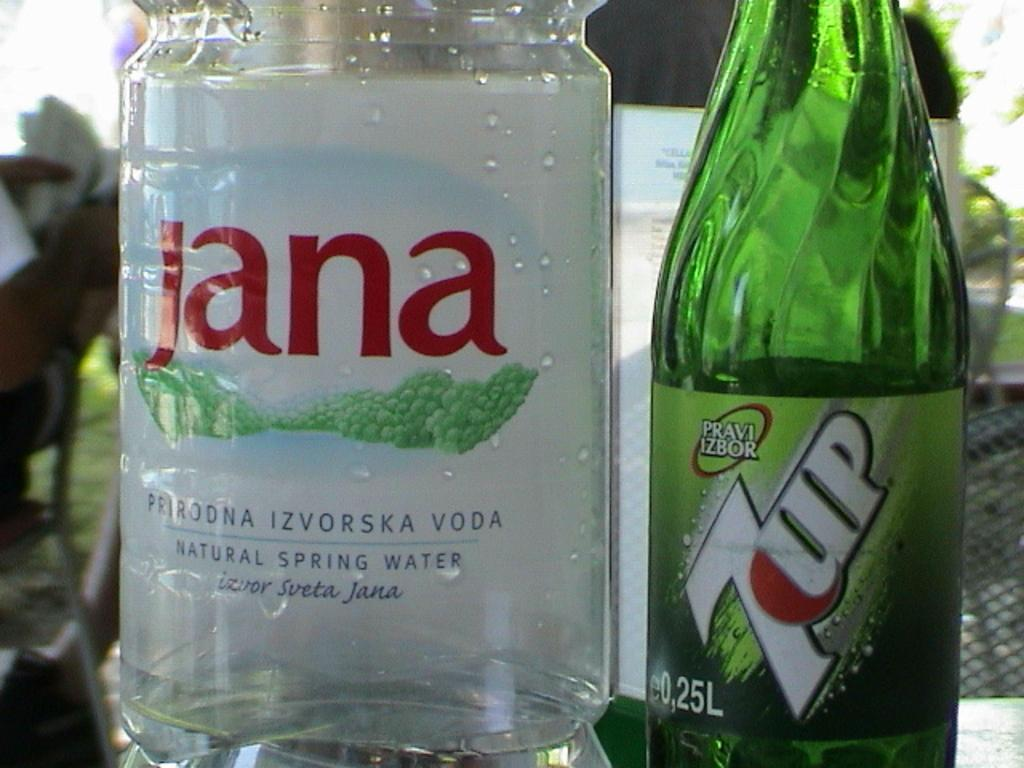<image>
Present a compact description of the photo's key features. Deciding on whether to drink spring water or a 7UP. 